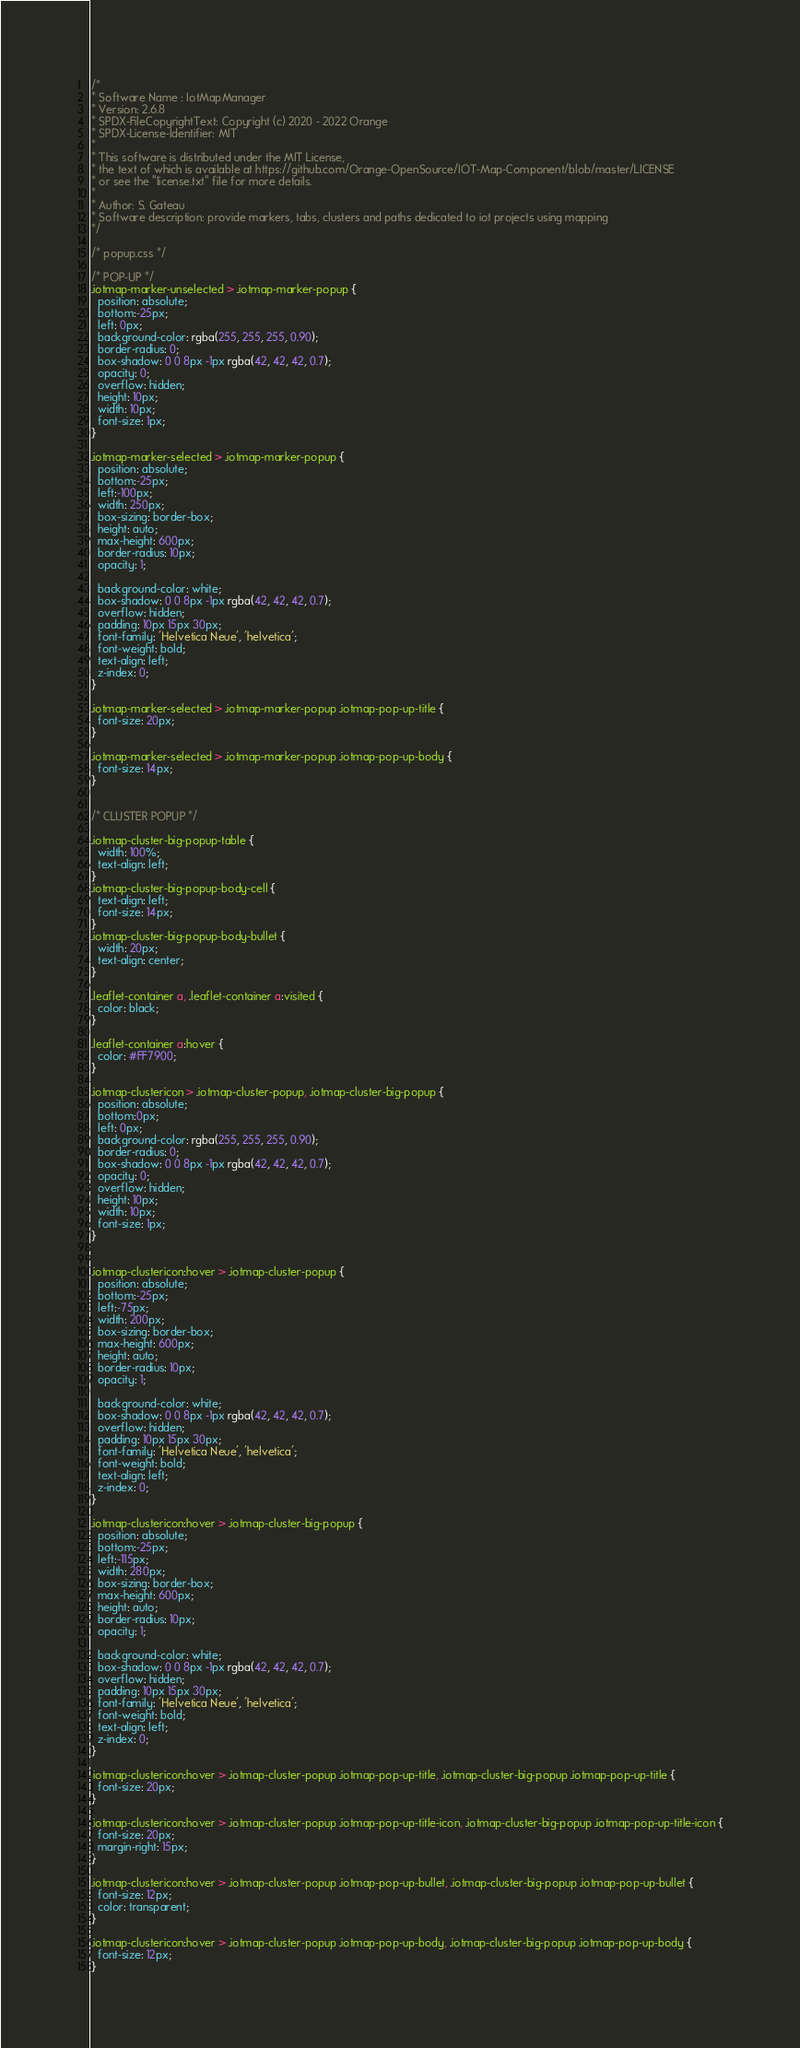Convert code to text. <code><loc_0><loc_0><loc_500><loc_500><_CSS_>/*
* Software Name : IotMapManager
* Version: 2.6.8
* SPDX-FileCopyrightText: Copyright (c) 2020 - 2022 Orange
* SPDX-License-Identifier: MIT
*
* This software is distributed under the MIT License,
* the text of which is available at https://github.com/Orange-OpenSource/IOT-Map-Component/blob/master/LICENSE
* or see the "license.txt" file for more details.
*
* Author: S. Gateau
* Software description: provide markers, tabs, clusters and paths dedicated to iot projects using mapping
*/

/* popup.css */

/* POP-UP */
.iotmap-marker-unselected > .iotmap-marker-popup {
  position: absolute;
  bottom:-25px;
  left: 0px;
  background-color: rgba(255, 255, 255, 0.90);
  border-radius: 0;
  box-shadow: 0 0 8px -1px rgba(42, 42, 42, 0.7);
  opacity: 0;
  overflow: hidden;
  height: 10px;
  width: 10px;
  font-size: 1px;
}

.iotmap-marker-selected > .iotmap-marker-popup {
  position: absolute;
  bottom:-25px;
  left:-100px;
  width: 250px;
  box-sizing: border-box;
  height: auto;
  max-height: 600px;
  border-radius: 10px;
  opacity: 1;

  background-color: white;
  box-shadow: 0 0 8px -1px rgba(42, 42, 42, 0.7);
  overflow: hidden;
  padding: 10px 15px 30px;
  font-family: 'Helvetica Neue', 'helvetica';
  font-weight: bold;
  text-align: left;
  z-index: 0;
}

.iotmap-marker-selected > .iotmap-marker-popup .iotmap-pop-up-title {
  font-size: 20px;
}

.iotmap-marker-selected > .iotmap-marker-popup .iotmap-pop-up-body {
  font-size: 14px;
}


/* CLUSTER POPUP */

.iotmap-cluster-big-popup-table {
  width: 100%;
  text-align: left;
}
.iotmap-cluster-big-popup-body-cell {
  text-align: left;
  font-size: 14px;
}
.iotmap-cluster-big-popup-body-bullet {
  width: 20px;
  text-align: center;
}

.leaflet-container a, .leaflet-container a:visited {
  color: black;
}

.leaflet-container a:hover {
  color: #FF7900;
}

.iotmap-clustericon > .iotmap-cluster-popup, .iotmap-cluster-big-popup {
  position: absolute;
  bottom:0px;
  left: 0px;
  background-color: rgba(255, 255, 255, 0.90);
  border-radius: 0;
  box-shadow: 0 0 8px -1px rgba(42, 42, 42, 0.7);
  opacity: 0;
  overflow: hidden;
  height: 10px;
  width: 10px;
  font-size: 1px;
}


.iotmap-clustericon:hover > .iotmap-cluster-popup {
  position: absolute;
  bottom:-25px;
  left:-75px;
  width: 200px;
  box-sizing: border-box;
  max-height: 600px;
  height: auto;
  border-radius: 10px;
  opacity: 1;

  background-color: white;
  box-shadow: 0 0 8px -1px rgba(42, 42, 42, 0.7);
  overflow: hidden;
  padding: 10px 15px 30px;
  font-family: 'Helvetica Neue', 'helvetica';
  font-weight: bold;
  text-align: left;
  z-index: 0;
}

.iotmap-clustericon:hover > .iotmap-cluster-big-popup {
  position: absolute;
  bottom:-25px;
  left:-115px;
  width: 280px;
  box-sizing: border-box;
  max-height: 600px;
  height: auto;
  border-radius: 10px;
  opacity: 1;

  background-color: white;
  box-shadow: 0 0 8px -1px rgba(42, 42, 42, 0.7);
  overflow: hidden;
  padding: 10px 15px 30px;
  font-family: 'Helvetica Neue', 'helvetica';
  font-weight: bold;
  text-align: left;
  z-index: 0;
}

.iotmap-clustericon:hover > .iotmap-cluster-popup .iotmap-pop-up-title, .iotmap-cluster-big-popup .iotmap-pop-up-title {
  font-size: 20px;
}

.iotmap-clustericon:hover > .iotmap-cluster-popup .iotmap-pop-up-title-icon, .iotmap-cluster-big-popup .iotmap-pop-up-title-icon {
  font-size: 20px;
  margin-right: 15px;
}

.iotmap-clustericon:hover > .iotmap-cluster-popup .iotmap-pop-up-bullet, .iotmap-cluster-big-popup .iotmap-pop-up-bullet {
  font-size: 12px;
  color: transparent;
}

.iotmap-clustericon:hover > .iotmap-cluster-popup .iotmap-pop-up-body, .iotmap-cluster-big-popup .iotmap-pop-up-body {
  font-size: 12px;
}





</code> 